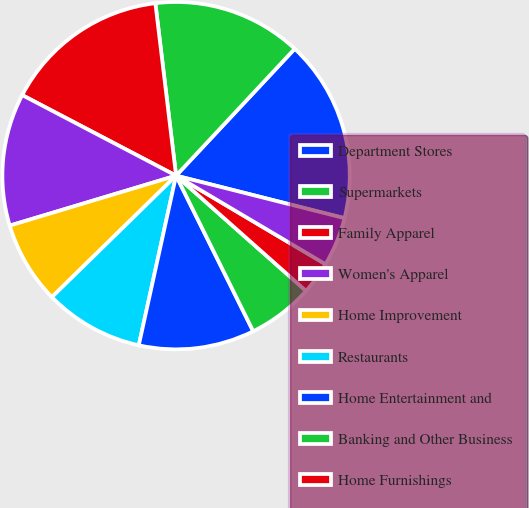Convert chart to OTSL. <chart><loc_0><loc_0><loc_500><loc_500><pie_chart><fcel>Department Stores<fcel>Supermarkets<fcel>Family Apparel<fcel>Women's Apparel<fcel>Home Improvement<fcel>Restaurants<fcel>Home Entertainment and<fcel>Banking and Other Business<fcel>Home Furnishings<fcel>Personal services<nl><fcel>16.97%<fcel>13.87%<fcel>15.42%<fcel>12.32%<fcel>7.68%<fcel>9.23%<fcel>10.77%<fcel>6.13%<fcel>3.03%<fcel>4.58%<nl></chart> 